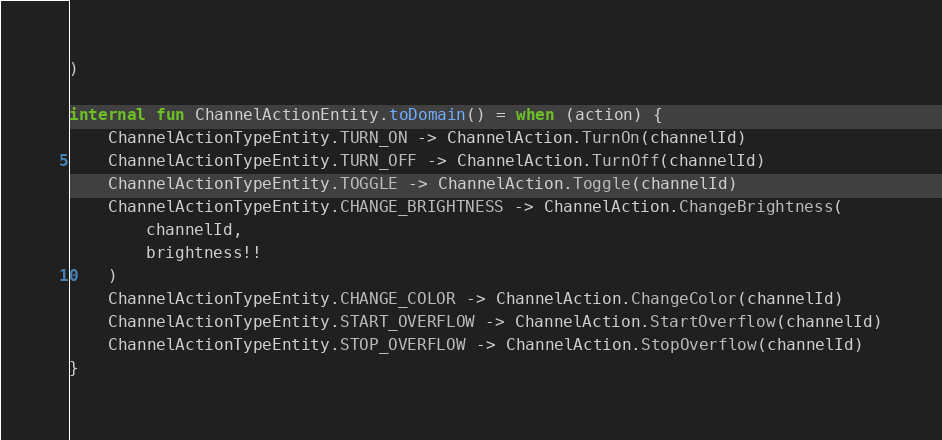Convert code to text. <code><loc_0><loc_0><loc_500><loc_500><_Kotlin_>)

internal fun ChannelActionEntity.toDomain() = when (action) {
    ChannelActionTypeEntity.TURN_ON -> ChannelAction.TurnOn(channelId)
    ChannelActionTypeEntity.TURN_OFF -> ChannelAction.TurnOff(channelId)
    ChannelActionTypeEntity.TOGGLE -> ChannelAction.Toggle(channelId)
    ChannelActionTypeEntity.CHANGE_BRIGHTNESS -> ChannelAction.ChangeBrightness(
        channelId,
        brightness!!
    )
    ChannelActionTypeEntity.CHANGE_COLOR -> ChannelAction.ChangeColor(channelId)
    ChannelActionTypeEntity.START_OVERFLOW -> ChannelAction.StartOverflow(channelId)
    ChannelActionTypeEntity.STOP_OVERFLOW -> ChannelAction.StopOverflow(channelId)
}
</code> 